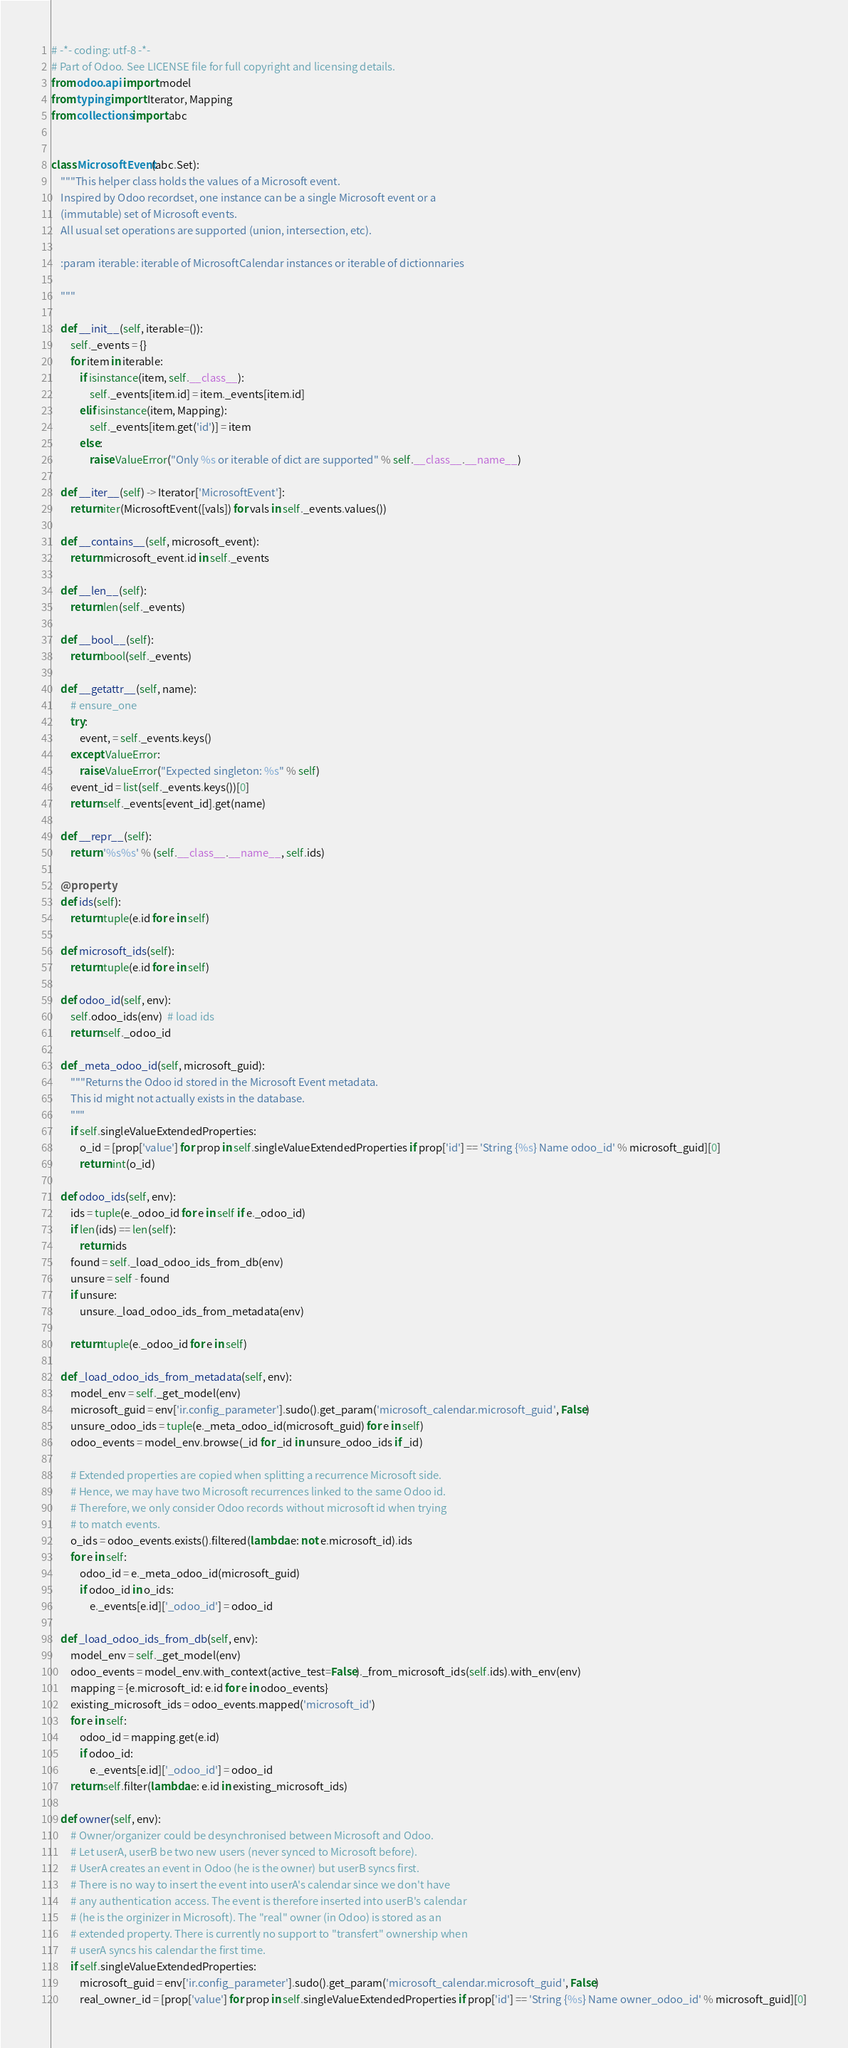<code> <loc_0><loc_0><loc_500><loc_500><_Python_># -*- coding: utf-8 -*-
# Part of Odoo. See LICENSE file for full copyright and licensing details.
from odoo.api import model
from typing import Iterator, Mapping
from collections import abc


class MicrosoftEvent(abc.Set):
    """This helper class holds the values of a Microsoft event.
    Inspired by Odoo recordset, one instance can be a single Microsoft event or a
    (immutable) set of Microsoft events.
    All usual set operations are supported (union, intersection, etc).

    :param iterable: iterable of MicrosoftCalendar instances or iterable of dictionnaries

    """

    def __init__(self, iterable=()):
        self._events = {}
        for item in iterable:
            if isinstance(item, self.__class__):
                self._events[item.id] = item._events[item.id]
            elif isinstance(item, Mapping):
                self._events[item.get('id')] = item
            else:
                raise ValueError("Only %s or iterable of dict are supported" % self.__class__.__name__)

    def __iter__(self) -> Iterator['MicrosoftEvent']:
        return iter(MicrosoftEvent([vals]) for vals in self._events.values())

    def __contains__(self, microsoft_event):
        return microsoft_event.id in self._events

    def __len__(self):
        return len(self._events)

    def __bool__(self):
        return bool(self._events)

    def __getattr__(self, name):
        # ensure_one
        try:
            event, = self._events.keys()
        except ValueError:
            raise ValueError("Expected singleton: %s" % self)
        event_id = list(self._events.keys())[0]
        return self._events[event_id].get(name)

    def __repr__(self):
        return '%s%s' % (self.__class__.__name__, self.ids)

    @property
    def ids(self):
        return tuple(e.id for e in self)

    def microsoft_ids(self):
        return tuple(e.id for e in self)

    def odoo_id(self, env):
        self.odoo_ids(env)  # load ids
        return self._odoo_id

    def _meta_odoo_id(self, microsoft_guid):
        """Returns the Odoo id stored in the Microsoft Event metadata.
        This id might not actually exists in the database.
        """
        if self.singleValueExtendedProperties:
            o_id = [prop['value'] for prop in self.singleValueExtendedProperties if prop['id'] == 'String {%s} Name odoo_id' % microsoft_guid][0]
            return int(o_id)

    def odoo_ids(self, env):
        ids = tuple(e._odoo_id for e in self if e._odoo_id)
        if len(ids) == len(self):
            return ids
        found = self._load_odoo_ids_from_db(env)
        unsure = self - found
        if unsure:
            unsure._load_odoo_ids_from_metadata(env)

        return tuple(e._odoo_id for e in self)

    def _load_odoo_ids_from_metadata(self, env):
        model_env = self._get_model(env)
        microsoft_guid = env['ir.config_parameter'].sudo().get_param('microsoft_calendar.microsoft_guid', False)
        unsure_odoo_ids = tuple(e._meta_odoo_id(microsoft_guid) for e in self)
        odoo_events = model_env.browse(_id for _id in unsure_odoo_ids if _id)

        # Extended properties are copied when splitting a recurrence Microsoft side.
        # Hence, we may have two Microsoft recurrences linked to the same Odoo id.
        # Therefore, we only consider Odoo records without microsoft id when trying
        # to match events.
        o_ids = odoo_events.exists().filtered(lambda e: not e.microsoft_id).ids
        for e in self:
            odoo_id = e._meta_odoo_id(microsoft_guid)
            if odoo_id in o_ids:
                e._events[e.id]['_odoo_id'] = odoo_id

    def _load_odoo_ids_from_db(self, env):
        model_env = self._get_model(env)
        odoo_events = model_env.with_context(active_test=False)._from_microsoft_ids(self.ids).with_env(env)
        mapping = {e.microsoft_id: e.id for e in odoo_events}
        existing_microsoft_ids = odoo_events.mapped('microsoft_id')
        for e in self:
            odoo_id = mapping.get(e.id)
            if odoo_id:
                e._events[e.id]['_odoo_id'] = odoo_id
        return self.filter(lambda e: e.id in existing_microsoft_ids)

    def owner(self, env):
        # Owner/organizer could be desynchronised between Microsoft and Odoo.
        # Let userA, userB be two new users (never synced to Microsoft before).
        # UserA creates an event in Odoo (he is the owner) but userB syncs first.
        # There is no way to insert the event into userA's calendar since we don't have
        # any authentication access. The event is therefore inserted into userB's calendar
        # (he is the orginizer in Microsoft). The "real" owner (in Odoo) is stored as an
        # extended property. There is currently no support to "transfert" ownership when
        # userA syncs his calendar the first time.
        if self.singleValueExtendedProperties:
            microsoft_guid = env['ir.config_parameter'].sudo().get_param('microsoft_calendar.microsoft_guid', False)
            real_owner_id = [prop['value'] for prop in self.singleValueExtendedProperties if prop['id'] == 'String {%s} Name owner_odoo_id' % microsoft_guid][0]</code> 